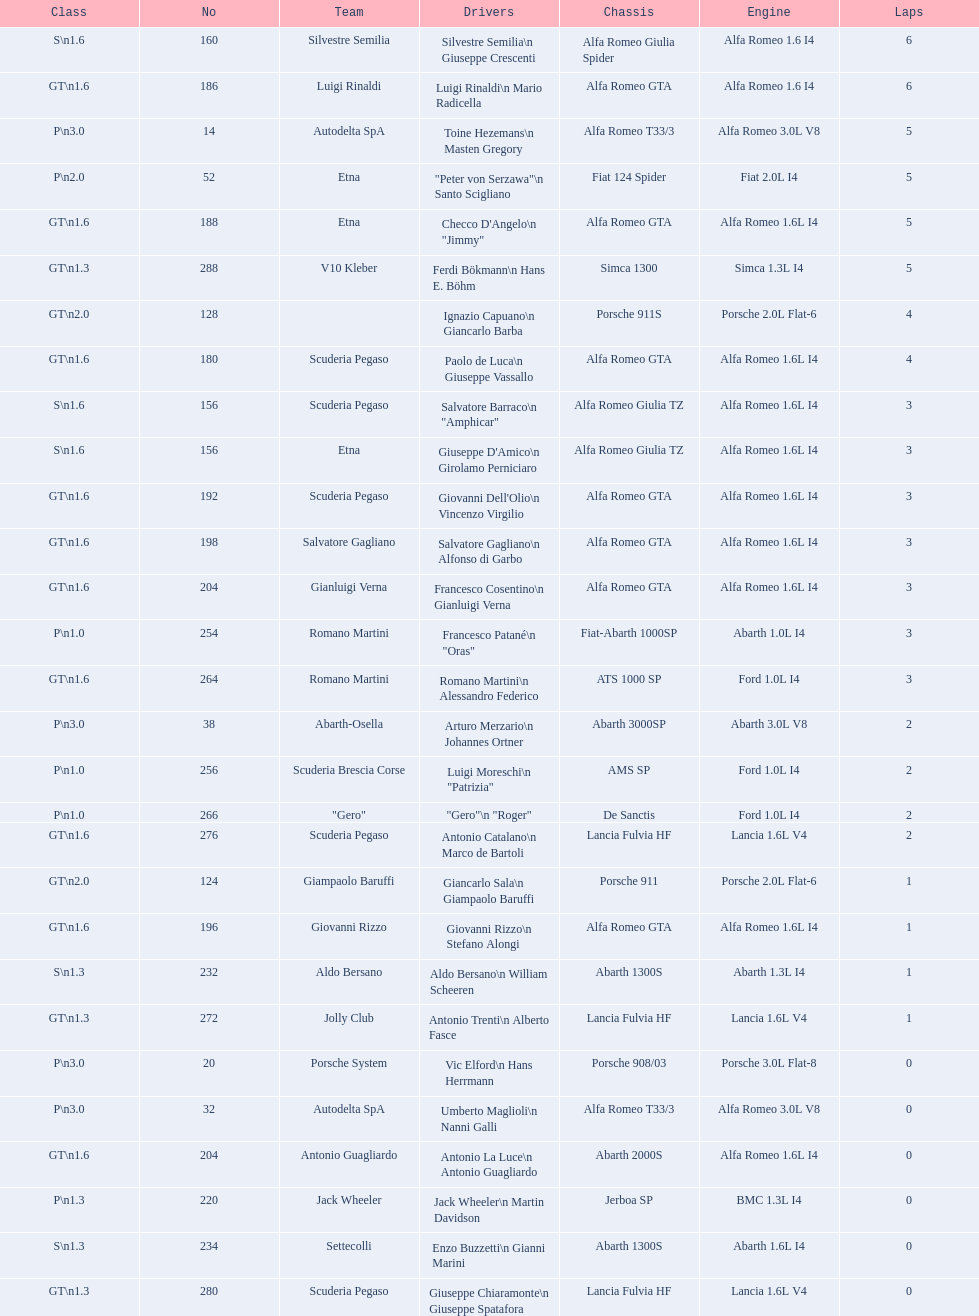Identify the sole american who did not complete the race. Masten Gregory. 